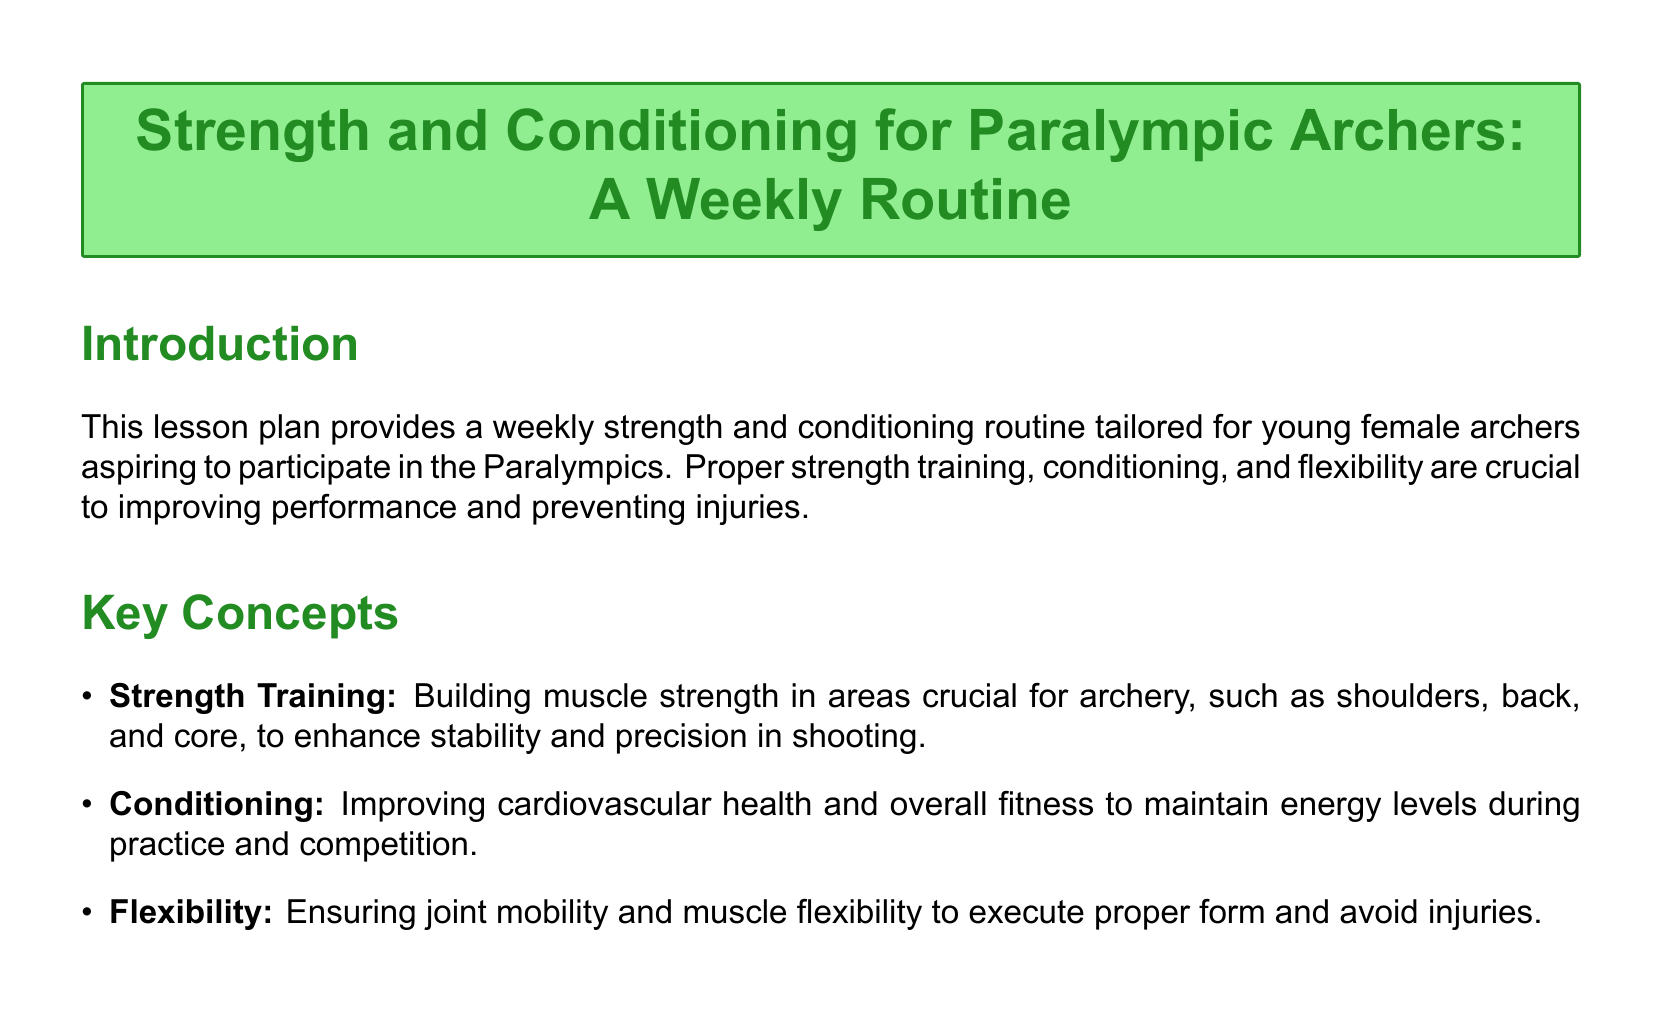What is the title of the lesson plan? The title of the lesson plan is clearly stated at the beginning of the document.
Answer: Strength and Conditioning for Paralympic Archers: A Weekly Routine How many days are included in the weekly routine? The weekly routine mentions specific activities for four days.
Answer: Four days What exercise is listed under Monday's strength training? The document specifies exercises for Monday's strength training section.
Answer: Dumbbell Shoulder Press How long should the elliptical trainer be used according to the plan? The time allocation for exercises is detailed in the conditioning section of Wednesday's routine.
Answer: 20 minutes What is emphasized in the tips section regarding hydration? The tips section highlights the importance of hydration during workouts.
Answer: Stay Hydrated What type of stretch is recommended for Saturday? The document includes various flexibility exercises throughout the week.
Answer: Quad Stretch What is the recommended number of sets for the dumbbell rows? The strength training routines specify the number of sets for various exercises.
Answer: 3 sets What should be consumed to support muscle recovery? The document advises on proper nutrition in the tips section.
Answer: Balanced diet rich in protein How long should jump rope be done on Saturday? The Saturday conditioning details the duration of the jump rope exercise.
Answer: 10 minutes 